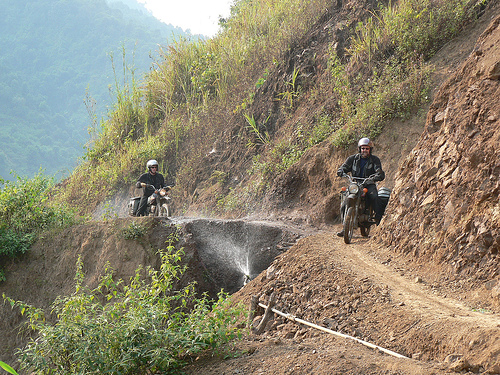Are the details of the ground relatively abundant?
A. No
B. Yes
Answer with the option's letter from the given choices directly.
 B. 